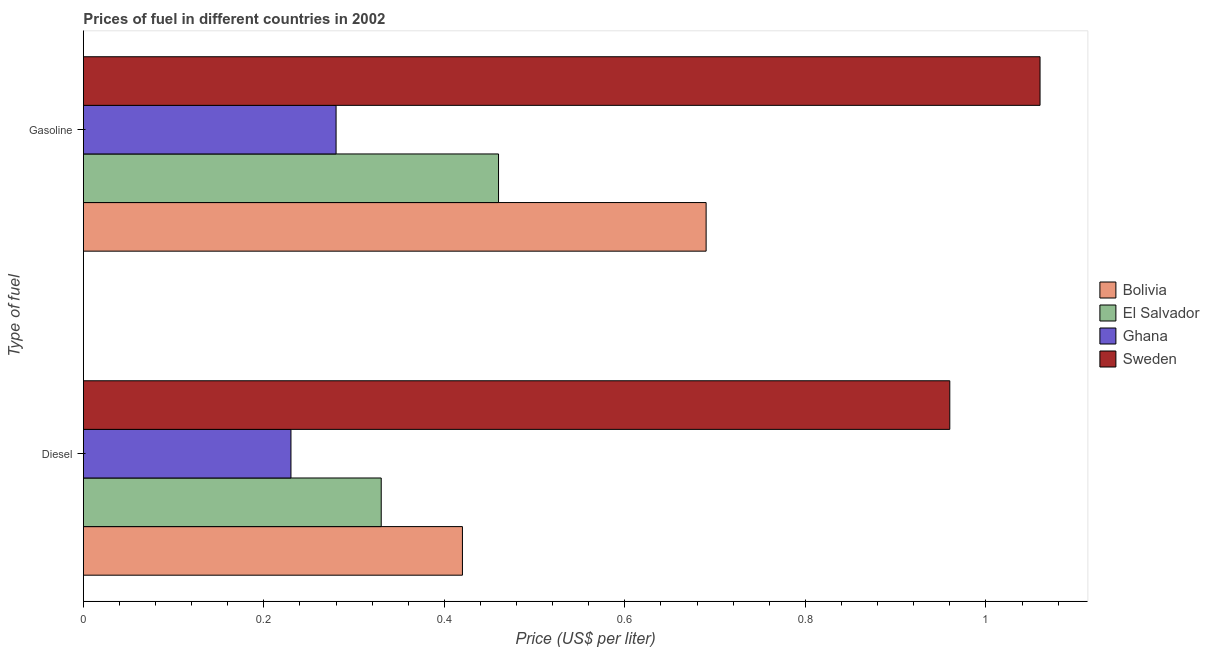How many different coloured bars are there?
Ensure brevity in your answer.  4. Are the number of bars on each tick of the Y-axis equal?
Make the answer very short. Yes. How many bars are there on the 2nd tick from the bottom?
Your answer should be compact. 4. What is the label of the 2nd group of bars from the top?
Your answer should be very brief. Diesel. What is the gasoline price in Bolivia?
Make the answer very short. 0.69. Across all countries, what is the maximum diesel price?
Make the answer very short. 0.96. Across all countries, what is the minimum diesel price?
Ensure brevity in your answer.  0.23. What is the total diesel price in the graph?
Provide a succinct answer. 1.94. What is the difference between the diesel price in El Salvador and that in Sweden?
Provide a succinct answer. -0.63. What is the difference between the gasoline price in El Salvador and the diesel price in Ghana?
Your response must be concise. 0.23. What is the average gasoline price per country?
Provide a succinct answer. 0.62. What is the difference between the diesel price and gasoline price in Sweden?
Provide a succinct answer. -0.1. In how many countries, is the gasoline price greater than 0.04 US$ per litre?
Your answer should be compact. 4. What is the ratio of the diesel price in El Salvador to that in Bolivia?
Provide a succinct answer. 0.79. Is the diesel price in Sweden less than that in Ghana?
Your response must be concise. No. What does the 2nd bar from the top in Gasoline represents?
Offer a very short reply. Ghana. What does the 1st bar from the bottom in Gasoline represents?
Your answer should be very brief. Bolivia. How many bars are there?
Offer a very short reply. 8. How many countries are there in the graph?
Provide a short and direct response. 4. Are the values on the major ticks of X-axis written in scientific E-notation?
Your answer should be very brief. No. Does the graph contain any zero values?
Your answer should be compact. No. Where does the legend appear in the graph?
Keep it short and to the point. Center right. How are the legend labels stacked?
Ensure brevity in your answer.  Vertical. What is the title of the graph?
Offer a terse response. Prices of fuel in different countries in 2002. Does "Sao Tome and Principe" appear as one of the legend labels in the graph?
Keep it short and to the point. No. What is the label or title of the X-axis?
Provide a succinct answer. Price (US$ per liter). What is the label or title of the Y-axis?
Your answer should be compact. Type of fuel. What is the Price (US$ per liter) in Bolivia in Diesel?
Provide a succinct answer. 0.42. What is the Price (US$ per liter) of El Salvador in Diesel?
Your answer should be compact. 0.33. What is the Price (US$ per liter) of Ghana in Diesel?
Offer a very short reply. 0.23. What is the Price (US$ per liter) of Bolivia in Gasoline?
Give a very brief answer. 0.69. What is the Price (US$ per liter) in El Salvador in Gasoline?
Your response must be concise. 0.46. What is the Price (US$ per liter) in Ghana in Gasoline?
Your response must be concise. 0.28. What is the Price (US$ per liter) in Sweden in Gasoline?
Keep it short and to the point. 1.06. Across all Type of fuel, what is the maximum Price (US$ per liter) in Bolivia?
Ensure brevity in your answer.  0.69. Across all Type of fuel, what is the maximum Price (US$ per liter) in El Salvador?
Your response must be concise. 0.46. Across all Type of fuel, what is the maximum Price (US$ per liter) of Ghana?
Offer a very short reply. 0.28. Across all Type of fuel, what is the maximum Price (US$ per liter) of Sweden?
Your response must be concise. 1.06. Across all Type of fuel, what is the minimum Price (US$ per liter) in Bolivia?
Give a very brief answer. 0.42. Across all Type of fuel, what is the minimum Price (US$ per liter) of El Salvador?
Your answer should be compact. 0.33. Across all Type of fuel, what is the minimum Price (US$ per liter) in Ghana?
Provide a short and direct response. 0.23. What is the total Price (US$ per liter) of Bolivia in the graph?
Your answer should be compact. 1.11. What is the total Price (US$ per liter) of El Salvador in the graph?
Your answer should be compact. 0.79. What is the total Price (US$ per liter) in Ghana in the graph?
Offer a terse response. 0.51. What is the total Price (US$ per liter) in Sweden in the graph?
Offer a terse response. 2.02. What is the difference between the Price (US$ per liter) of Bolivia in Diesel and that in Gasoline?
Your response must be concise. -0.27. What is the difference between the Price (US$ per liter) in El Salvador in Diesel and that in Gasoline?
Your answer should be compact. -0.13. What is the difference between the Price (US$ per liter) of Ghana in Diesel and that in Gasoline?
Provide a short and direct response. -0.05. What is the difference between the Price (US$ per liter) of Bolivia in Diesel and the Price (US$ per liter) of El Salvador in Gasoline?
Provide a short and direct response. -0.04. What is the difference between the Price (US$ per liter) in Bolivia in Diesel and the Price (US$ per liter) in Ghana in Gasoline?
Keep it short and to the point. 0.14. What is the difference between the Price (US$ per liter) of Bolivia in Diesel and the Price (US$ per liter) of Sweden in Gasoline?
Keep it short and to the point. -0.64. What is the difference between the Price (US$ per liter) in El Salvador in Diesel and the Price (US$ per liter) in Ghana in Gasoline?
Keep it short and to the point. 0.05. What is the difference between the Price (US$ per liter) in El Salvador in Diesel and the Price (US$ per liter) in Sweden in Gasoline?
Your answer should be compact. -0.73. What is the difference between the Price (US$ per liter) of Ghana in Diesel and the Price (US$ per liter) of Sweden in Gasoline?
Your response must be concise. -0.83. What is the average Price (US$ per liter) of Bolivia per Type of fuel?
Give a very brief answer. 0.56. What is the average Price (US$ per liter) in El Salvador per Type of fuel?
Make the answer very short. 0.4. What is the average Price (US$ per liter) of Ghana per Type of fuel?
Provide a short and direct response. 0.26. What is the difference between the Price (US$ per liter) of Bolivia and Price (US$ per liter) of El Salvador in Diesel?
Offer a very short reply. 0.09. What is the difference between the Price (US$ per liter) of Bolivia and Price (US$ per liter) of Ghana in Diesel?
Your answer should be very brief. 0.19. What is the difference between the Price (US$ per liter) of Bolivia and Price (US$ per liter) of Sweden in Diesel?
Offer a terse response. -0.54. What is the difference between the Price (US$ per liter) of El Salvador and Price (US$ per liter) of Ghana in Diesel?
Make the answer very short. 0.1. What is the difference between the Price (US$ per liter) of El Salvador and Price (US$ per liter) of Sweden in Diesel?
Offer a terse response. -0.63. What is the difference between the Price (US$ per liter) in Ghana and Price (US$ per liter) in Sweden in Diesel?
Ensure brevity in your answer.  -0.73. What is the difference between the Price (US$ per liter) in Bolivia and Price (US$ per liter) in El Salvador in Gasoline?
Give a very brief answer. 0.23. What is the difference between the Price (US$ per liter) of Bolivia and Price (US$ per liter) of Ghana in Gasoline?
Make the answer very short. 0.41. What is the difference between the Price (US$ per liter) of Bolivia and Price (US$ per liter) of Sweden in Gasoline?
Your answer should be compact. -0.37. What is the difference between the Price (US$ per liter) in El Salvador and Price (US$ per liter) in Ghana in Gasoline?
Provide a short and direct response. 0.18. What is the difference between the Price (US$ per liter) in Ghana and Price (US$ per liter) in Sweden in Gasoline?
Offer a terse response. -0.78. What is the ratio of the Price (US$ per liter) in Bolivia in Diesel to that in Gasoline?
Make the answer very short. 0.61. What is the ratio of the Price (US$ per liter) of El Salvador in Diesel to that in Gasoline?
Make the answer very short. 0.72. What is the ratio of the Price (US$ per liter) in Ghana in Diesel to that in Gasoline?
Your response must be concise. 0.82. What is the ratio of the Price (US$ per liter) in Sweden in Diesel to that in Gasoline?
Offer a terse response. 0.91. What is the difference between the highest and the second highest Price (US$ per liter) in Bolivia?
Your response must be concise. 0.27. What is the difference between the highest and the second highest Price (US$ per liter) in El Salvador?
Ensure brevity in your answer.  0.13. What is the difference between the highest and the lowest Price (US$ per liter) in Bolivia?
Ensure brevity in your answer.  0.27. What is the difference between the highest and the lowest Price (US$ per liter) in El Salvador?
Provide a short and direct response. 0.13. What is the difference between the highest and the lowest Price (US$ per liter) of Sweden?
Keep it short and to the point. 0.1. 